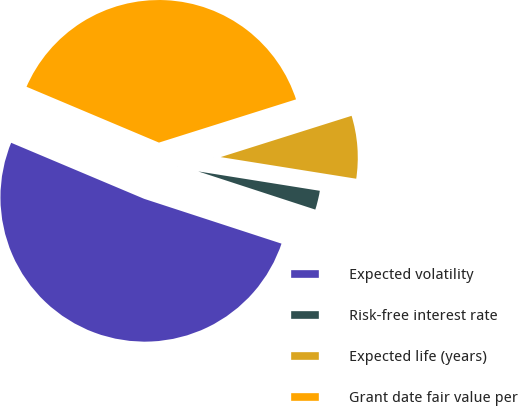Convert chart to OTSL. <chart><loc_0><loc_0><loc_500><loc_500><pie_chart><fcel>Expected volatility<fcel>Risk-free interest rate<fcel>Expected life (years)<fcel>Grant date fair value per<nl><fcel>51.33%<fcel>2.5%<fcel>7.38%<fcel>38.79%<nl></chart> 